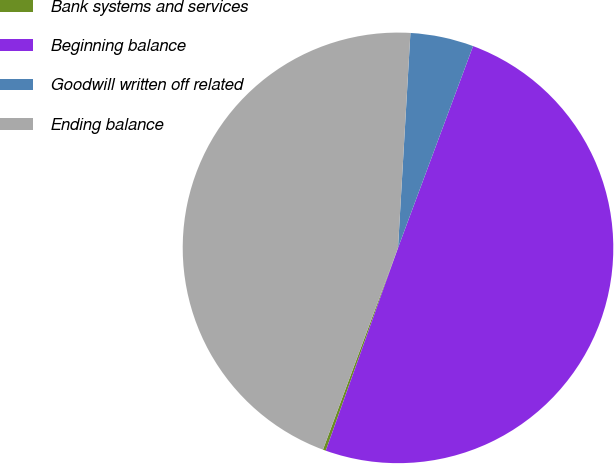Convert chart. <chart><loc_0><loc_0><loc_500><loc_500><pie_chart><fcel>Bank systems and services<fcel>Beginning balance<fcel>Goodwill written off related<fcel>Ending balance<nl><fcel>0.22%<fcel>49.78%<fcel>4.75%<fcel>45.25%<nl></chart> 